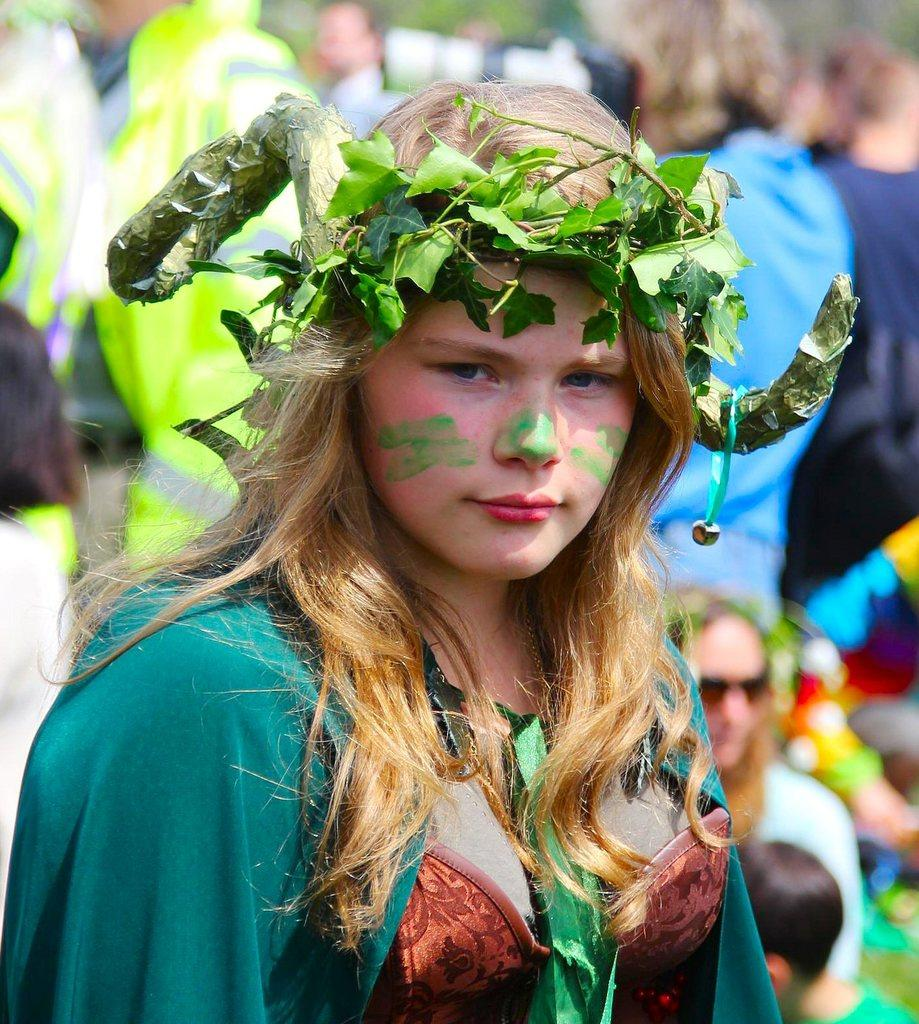Who is the main subject in the image? There is a woman in the image. What is on the woman's head? The woman has a crown on her head. Can you describe the background of the image? The background of the image is blurred. What can be seen in the background of the image? There is a camera visible in the background, and there are a few persons present as well. What type of rake is the woman using to clean the floor in the image? There is no rake present in the image, and the woman is not cleaning the floor. 